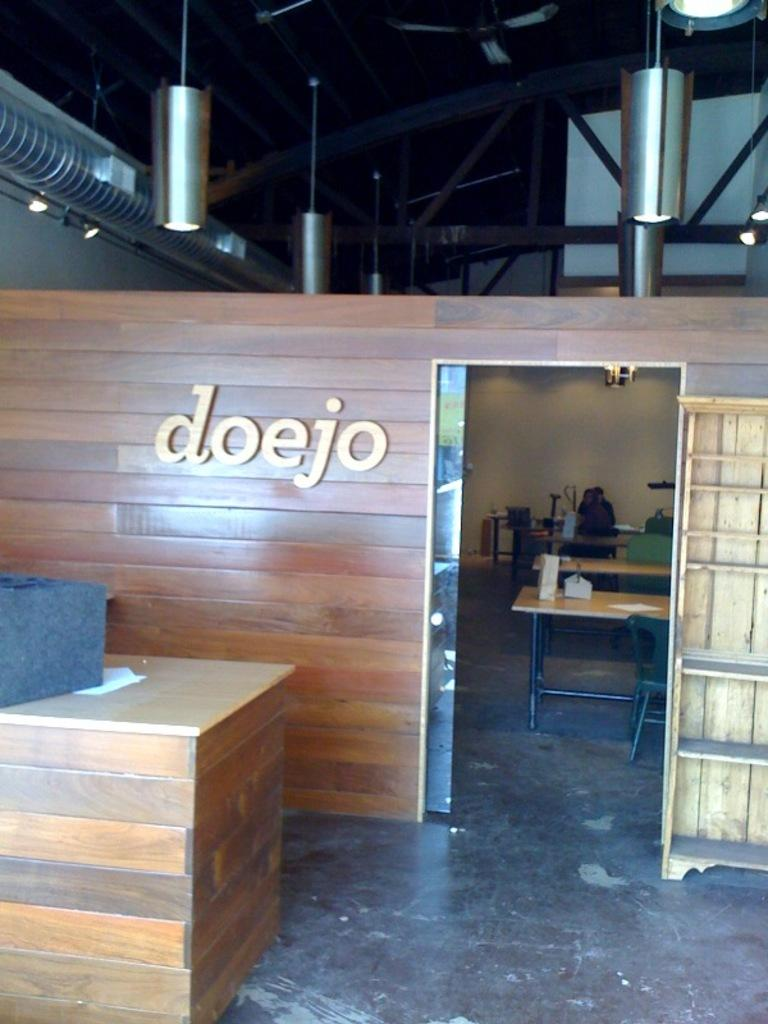<image>
Offer a succinct explanation of the picture presented. A wooden paneled wall with the words doejo on it. 